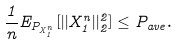Convert formula to latex. <formula><loc_0><loc_0><loc_500><loc_500>\frac { 1 } { n } E _ { P _ { X _ { 1 } ^ { n } } } [ | | X _ { 1 } ^ { n } | | _ { 2 } ^ { 2 } ] \leq P _ { a v e } .</formula> 